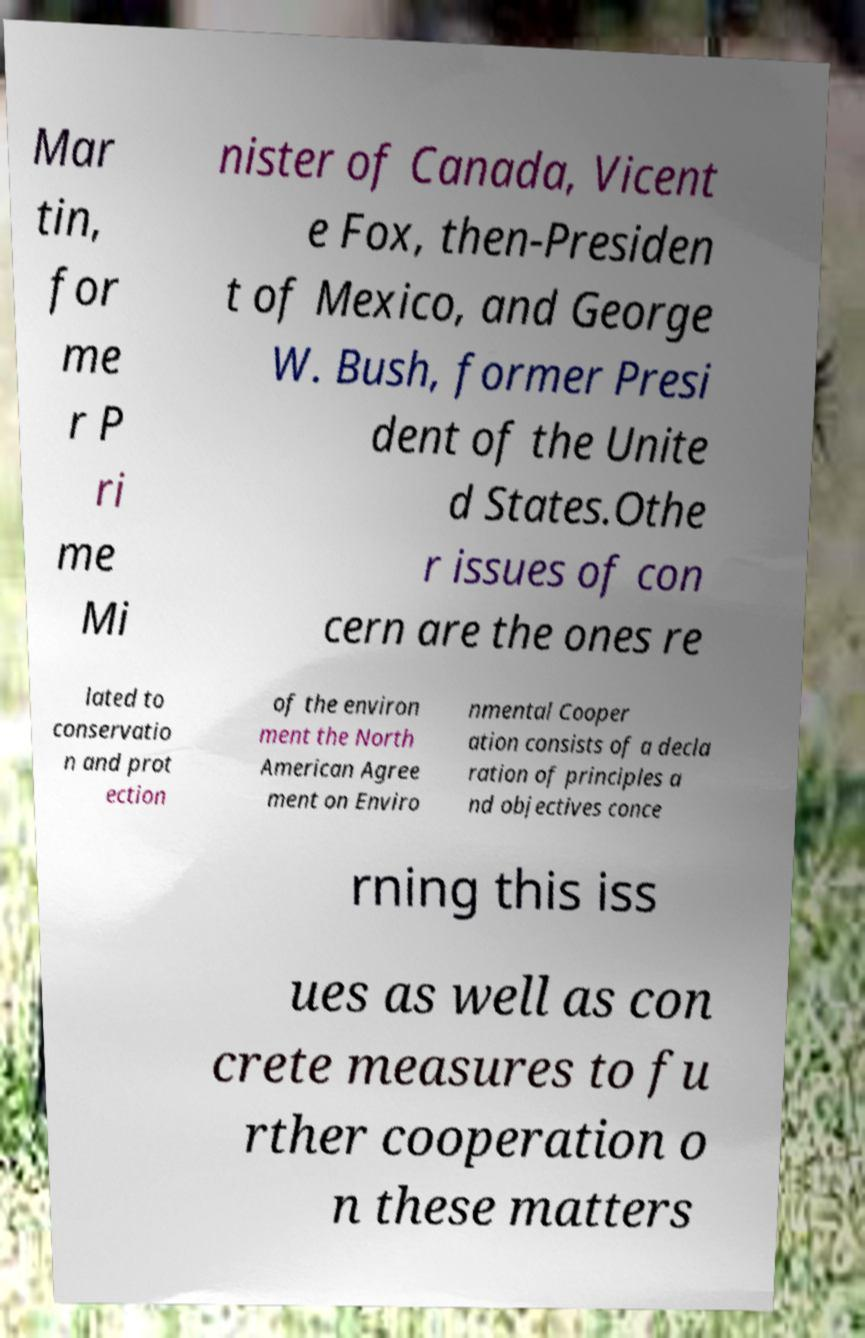I need the written content from this picture converted into text. Can you do that? Mar tin, for me r P ri me Mi nister of Canada, Vicent e Fox, then-Presiden t of Mexico, and George W. Bush, former Presi dent of the Unite d States.Othe r issues of con cern are the ones re lated to conservatio n and prot ection of the environ ment the North American Agree ment on Enviro nmental Cooper ation consists of a decla ration of principles a nd objectives conce rning this iss ues as well as con crete measures to fu rther cooperation o n these matters 